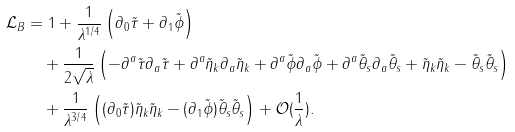Convert formula to latex. <formula><loc_0><loc_0><loc_500><loc_500>\mathcal { L } _ { B } & = 1 + \frac { 1 } { \lambda ^ { 1 / 4 } } \left ( \partial _ { 0 } \tilde { \tau } + \partial _ { 1 } \tilde { \phi } \right ) \\ & \quad + \frac { 1 } { 2 \sqrt { \lambda } } \left ( - \partial ^ { a } \tilde { \tau } \partial _ { a } \tilde { \tau } + \partial ^ { a } \tilde { \eta } _ { k } \partial _ { a } \tilde { \eta } _ { k } + \partial ^ { a } \tilde { \phi } \partial _ { a } \tilde { \phi } + \partial ^ { a } \tilde { \theta } _ { s } \partial _ { a } \tilde { \theta } _ { s } + \tilde { \eta } _ { k } \tilde { \eta } _ { k } - \tilde { \theta } _ { s } \tilde { \theta } _ { s } \right ) \\ & \quad + \frac { 1 } { \lambda ^ { 3 / 4 } } \left ( ( \partial _ { 0 } \tilde { \tau } ) \tilde { \eta } _ { k } \tilde { \eta } _ { k } - ( \partial _ { 1 } \tilde { \phi } ) \tilde { \theta } _ { s } \tilde { \theta } _ { s } \right ) + \mathcal { O } ( \frac { 1 } { \lambda } ) .</formula> 